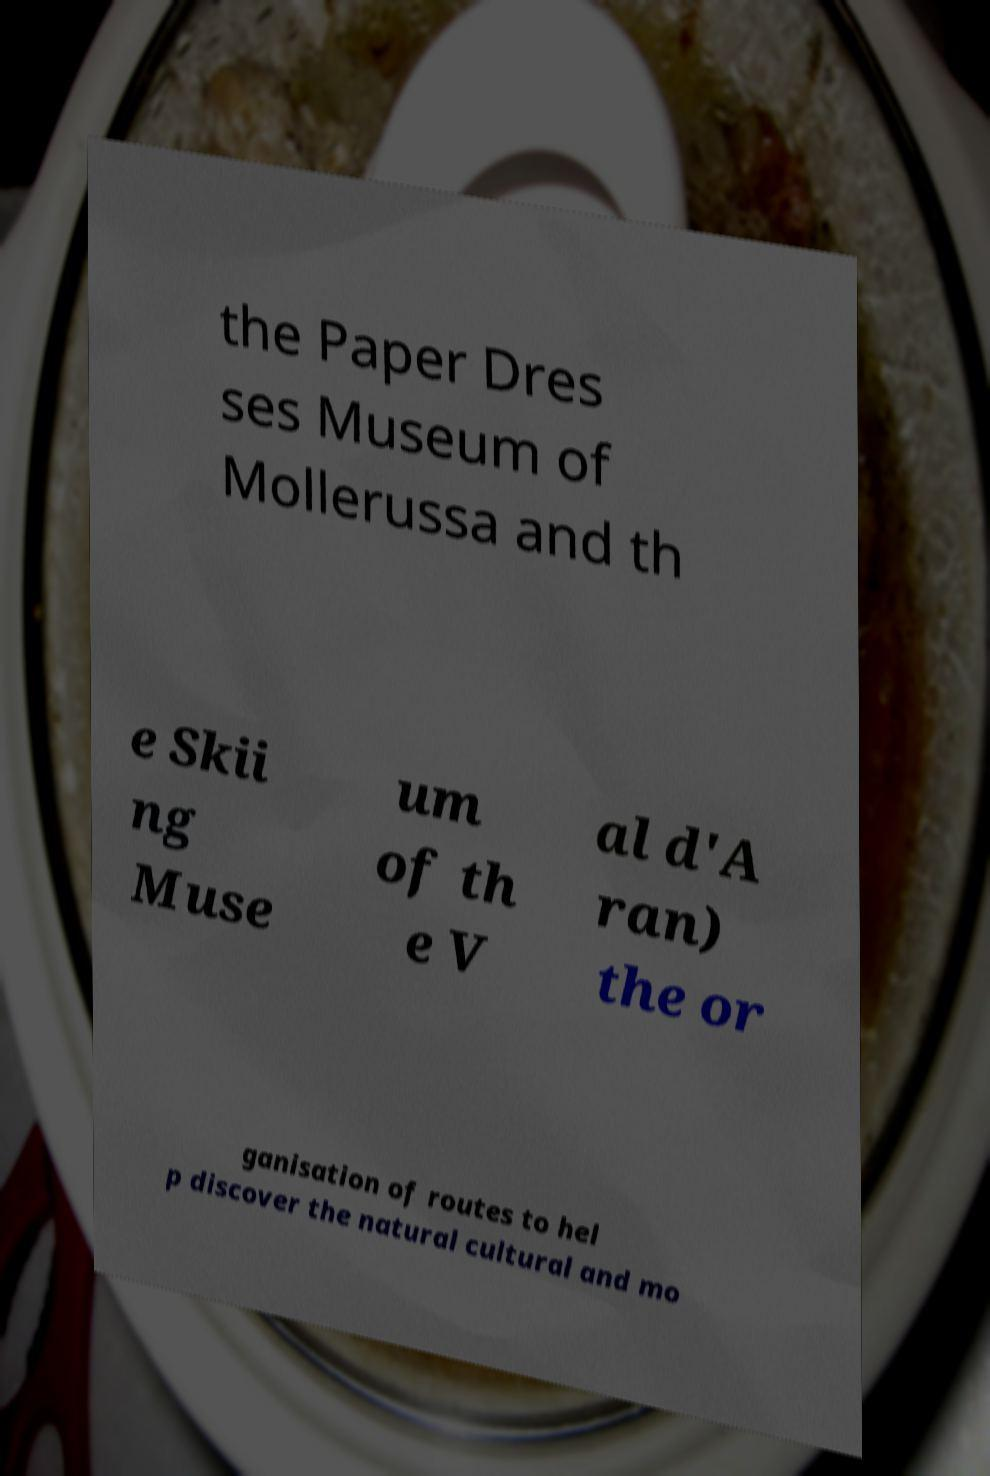Can you read and provide the text displayed in the image?This photo seems to have some interesting text. Can you extract and type it out for me? the Paper Dres ses Museum of Mollerussa and th e Skii ng Muse um of th e V al d'A ran) the or ganisation of routes to hel p discover the natural cultural and mo 